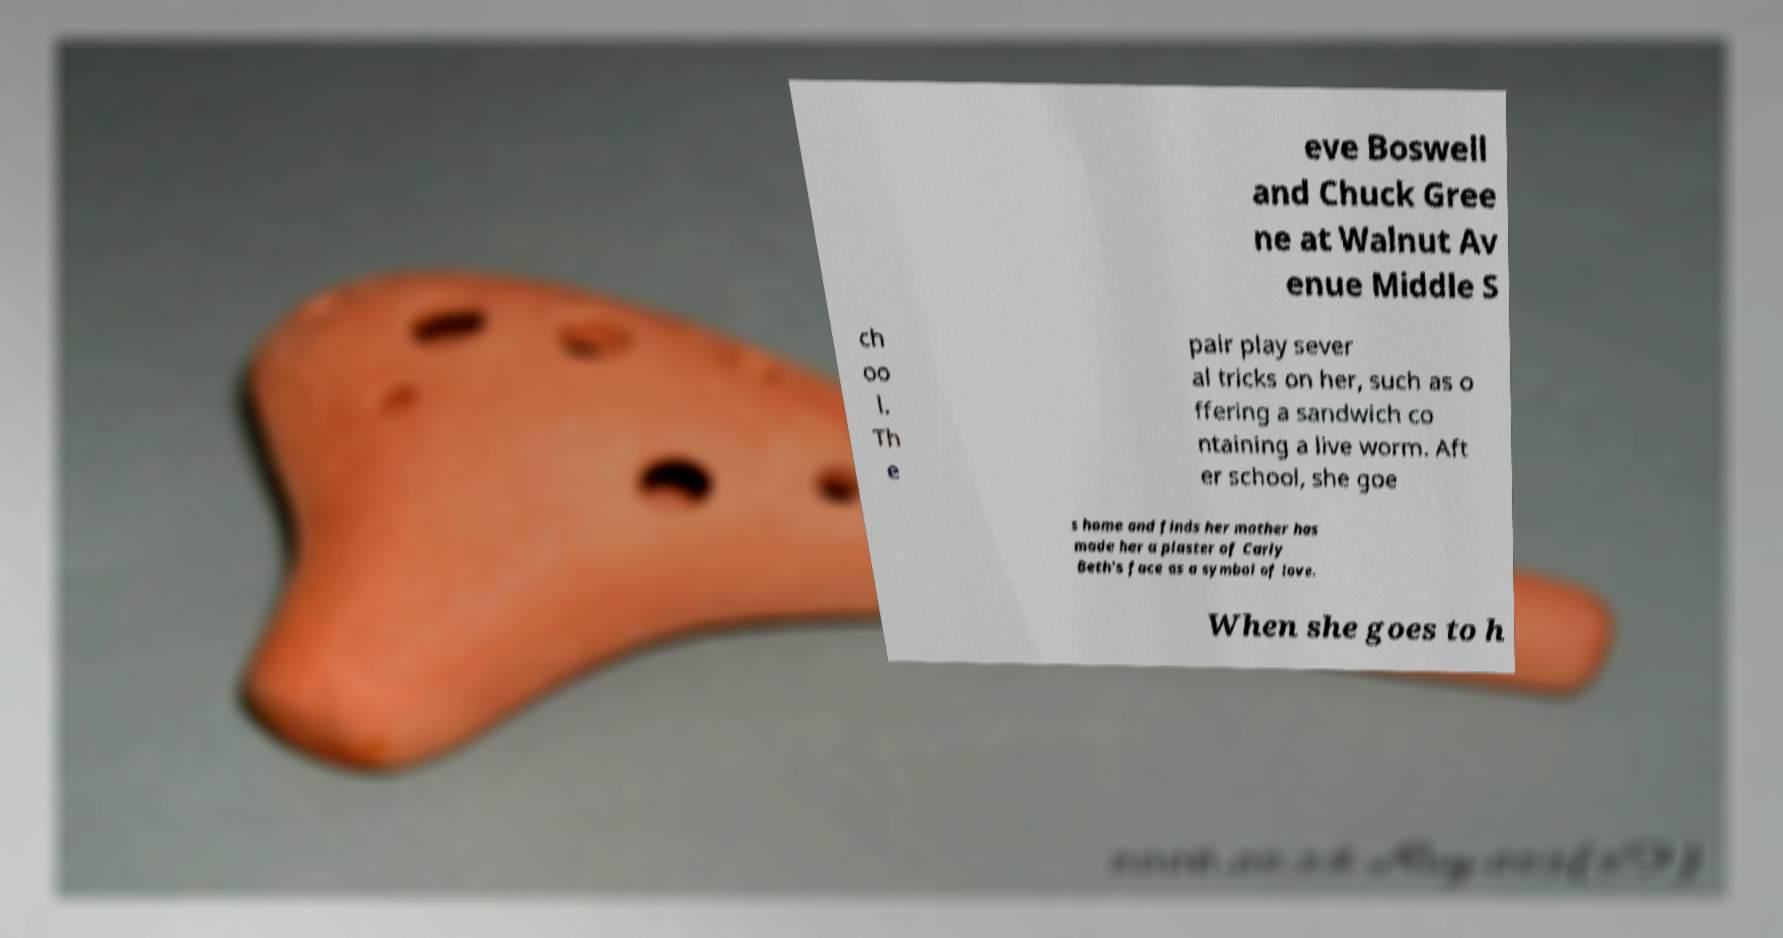Could you extract and type out the text from this image? eve Boswell and Chuck Gree ne at Walnut Av enue Middle S ch oo l. Th e pair play sever al tricks on her, such as o ffering a sandwich co ntaining a live worm. Aft er school, she goe s home and finds her mother has made her a plaster of Carly Beth's face as a symbol of love. When she goes to h 